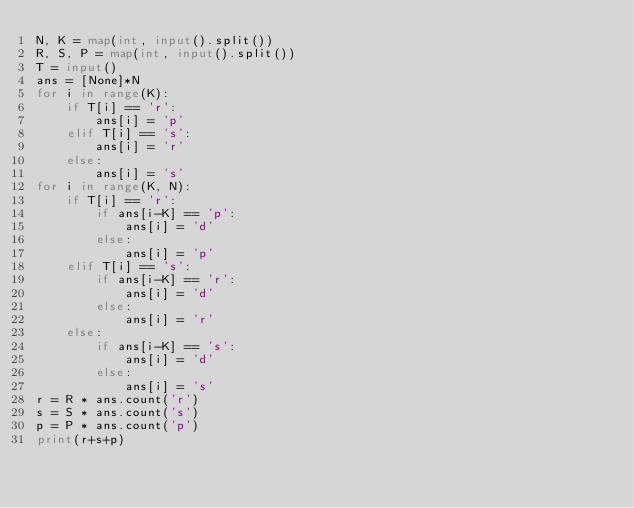Convert code to text. <code><loc_0><loc_0><loc_500><loc_500><_Python_>N, K = map(int, input().split())
R, S, P = map(int, input().split())
T = input()
ans = [None]*N
for i in range(K):
    if T[i] == 'r':
        ans[i] = 'p'
    elif T[i] == 's':
        ans[i] = 'r'
    else:
        ans[i] = 's'
for i in range(K, N):
    if T[i] == 'r':
        if ans[i-K] == 'p':
            ans[i] = 'd'
        else:
            ans[i] = 'p'
    elif T[i] == 's':
        if ans[i-K] == 'r':
            ans[i] = 'd'
        else:
            ans[i] = 'r'
    else:
        if ans[i-K] == 's':
            ans[i] = 'd'
        else:
            ans[i] = 's'
r = R * ans.count('r')
s = S * ans.count('s')
p = P * ans.count('p')
print(r+s+p)
</code> 